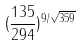Convert formula to latex. <formula><loc_0><loc_0><loc_500><loc_500>( \frac { 1 3 5 } { 2 9 4 } ) ^ { 9 / \sqrt { 3 5 9 } }</formula> 